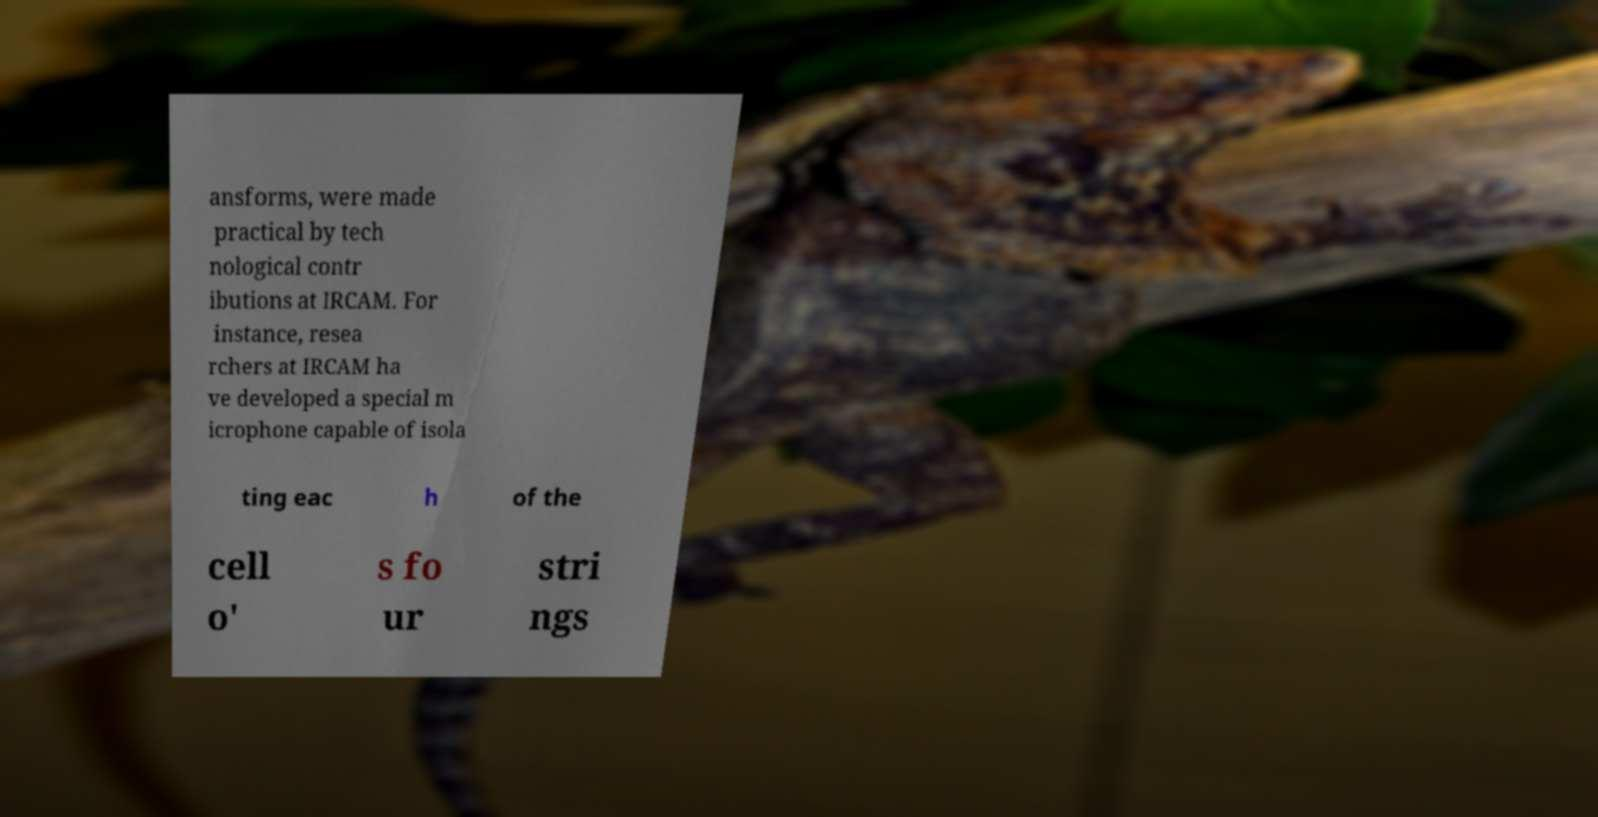Can you accurately transcribe the text from the provided image for me? ansforms, were made practical by tech nological contr ibutions at IRCAM. For instance, resea rchers at IRCAM ha ve developed a special m icrophone capable of isola ting eac h of the cell o' s fo ur stri ngs 